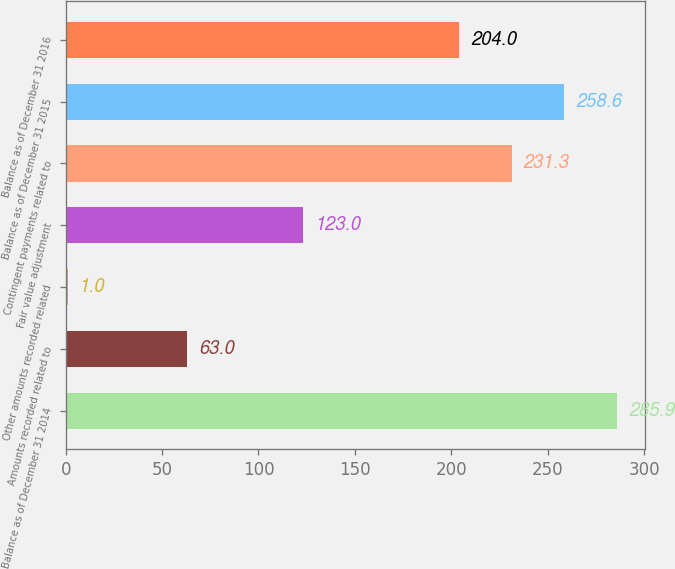Convert chart. <chart><loc_0><loc_0><loc_500><loc_500><bar_chart><fcel>Balance as of December 31 2014<fcel>Amounts recorded related to<fcel>Other amounts recorded related<fcel>Fair value adjustment<fcel>Contingent payments related to<fcel>Balance as of December 31 2015<fcel>Balance as of December 31 2016<nl><fcel>285.9<fcel>63<fcel>1<fcel>123<fcel>231.3<fcel>258.6<fcel>204<nl></chart> 